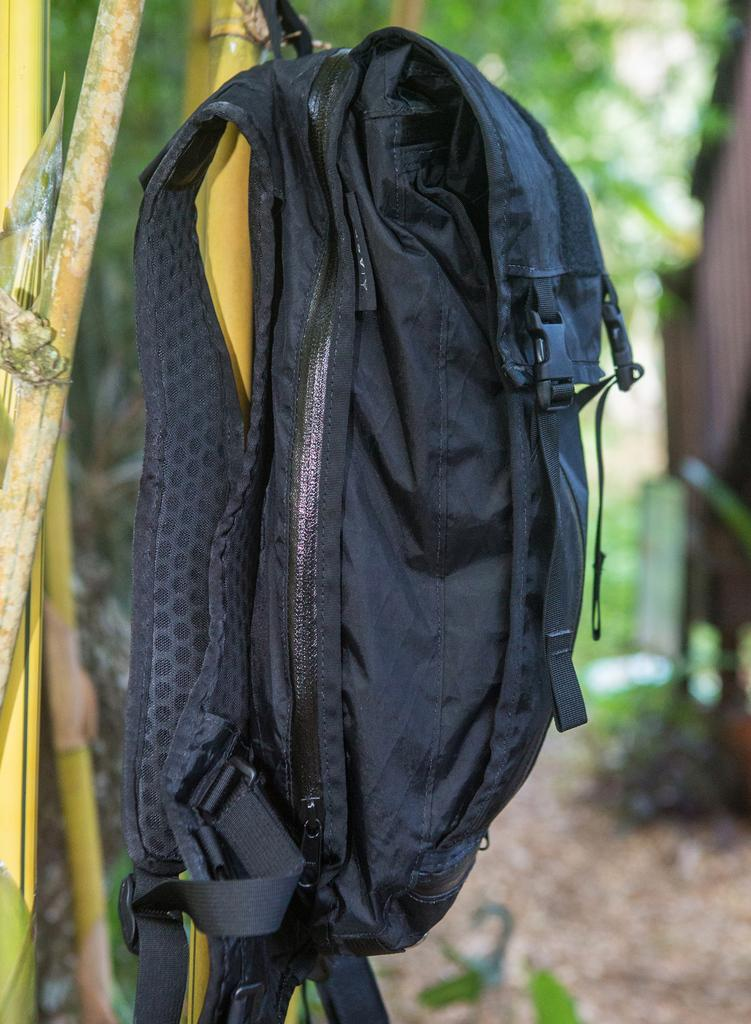What object is present in the image? There is a bag in the image. How is the bag positioned in the image? The bag is hanging on a stick. What type of account is associated with the bag in the image? There is no account associated with the bag in the image. In which direction is the bag facing in the image? The direction the bag is facing cannot be determined from the image. 